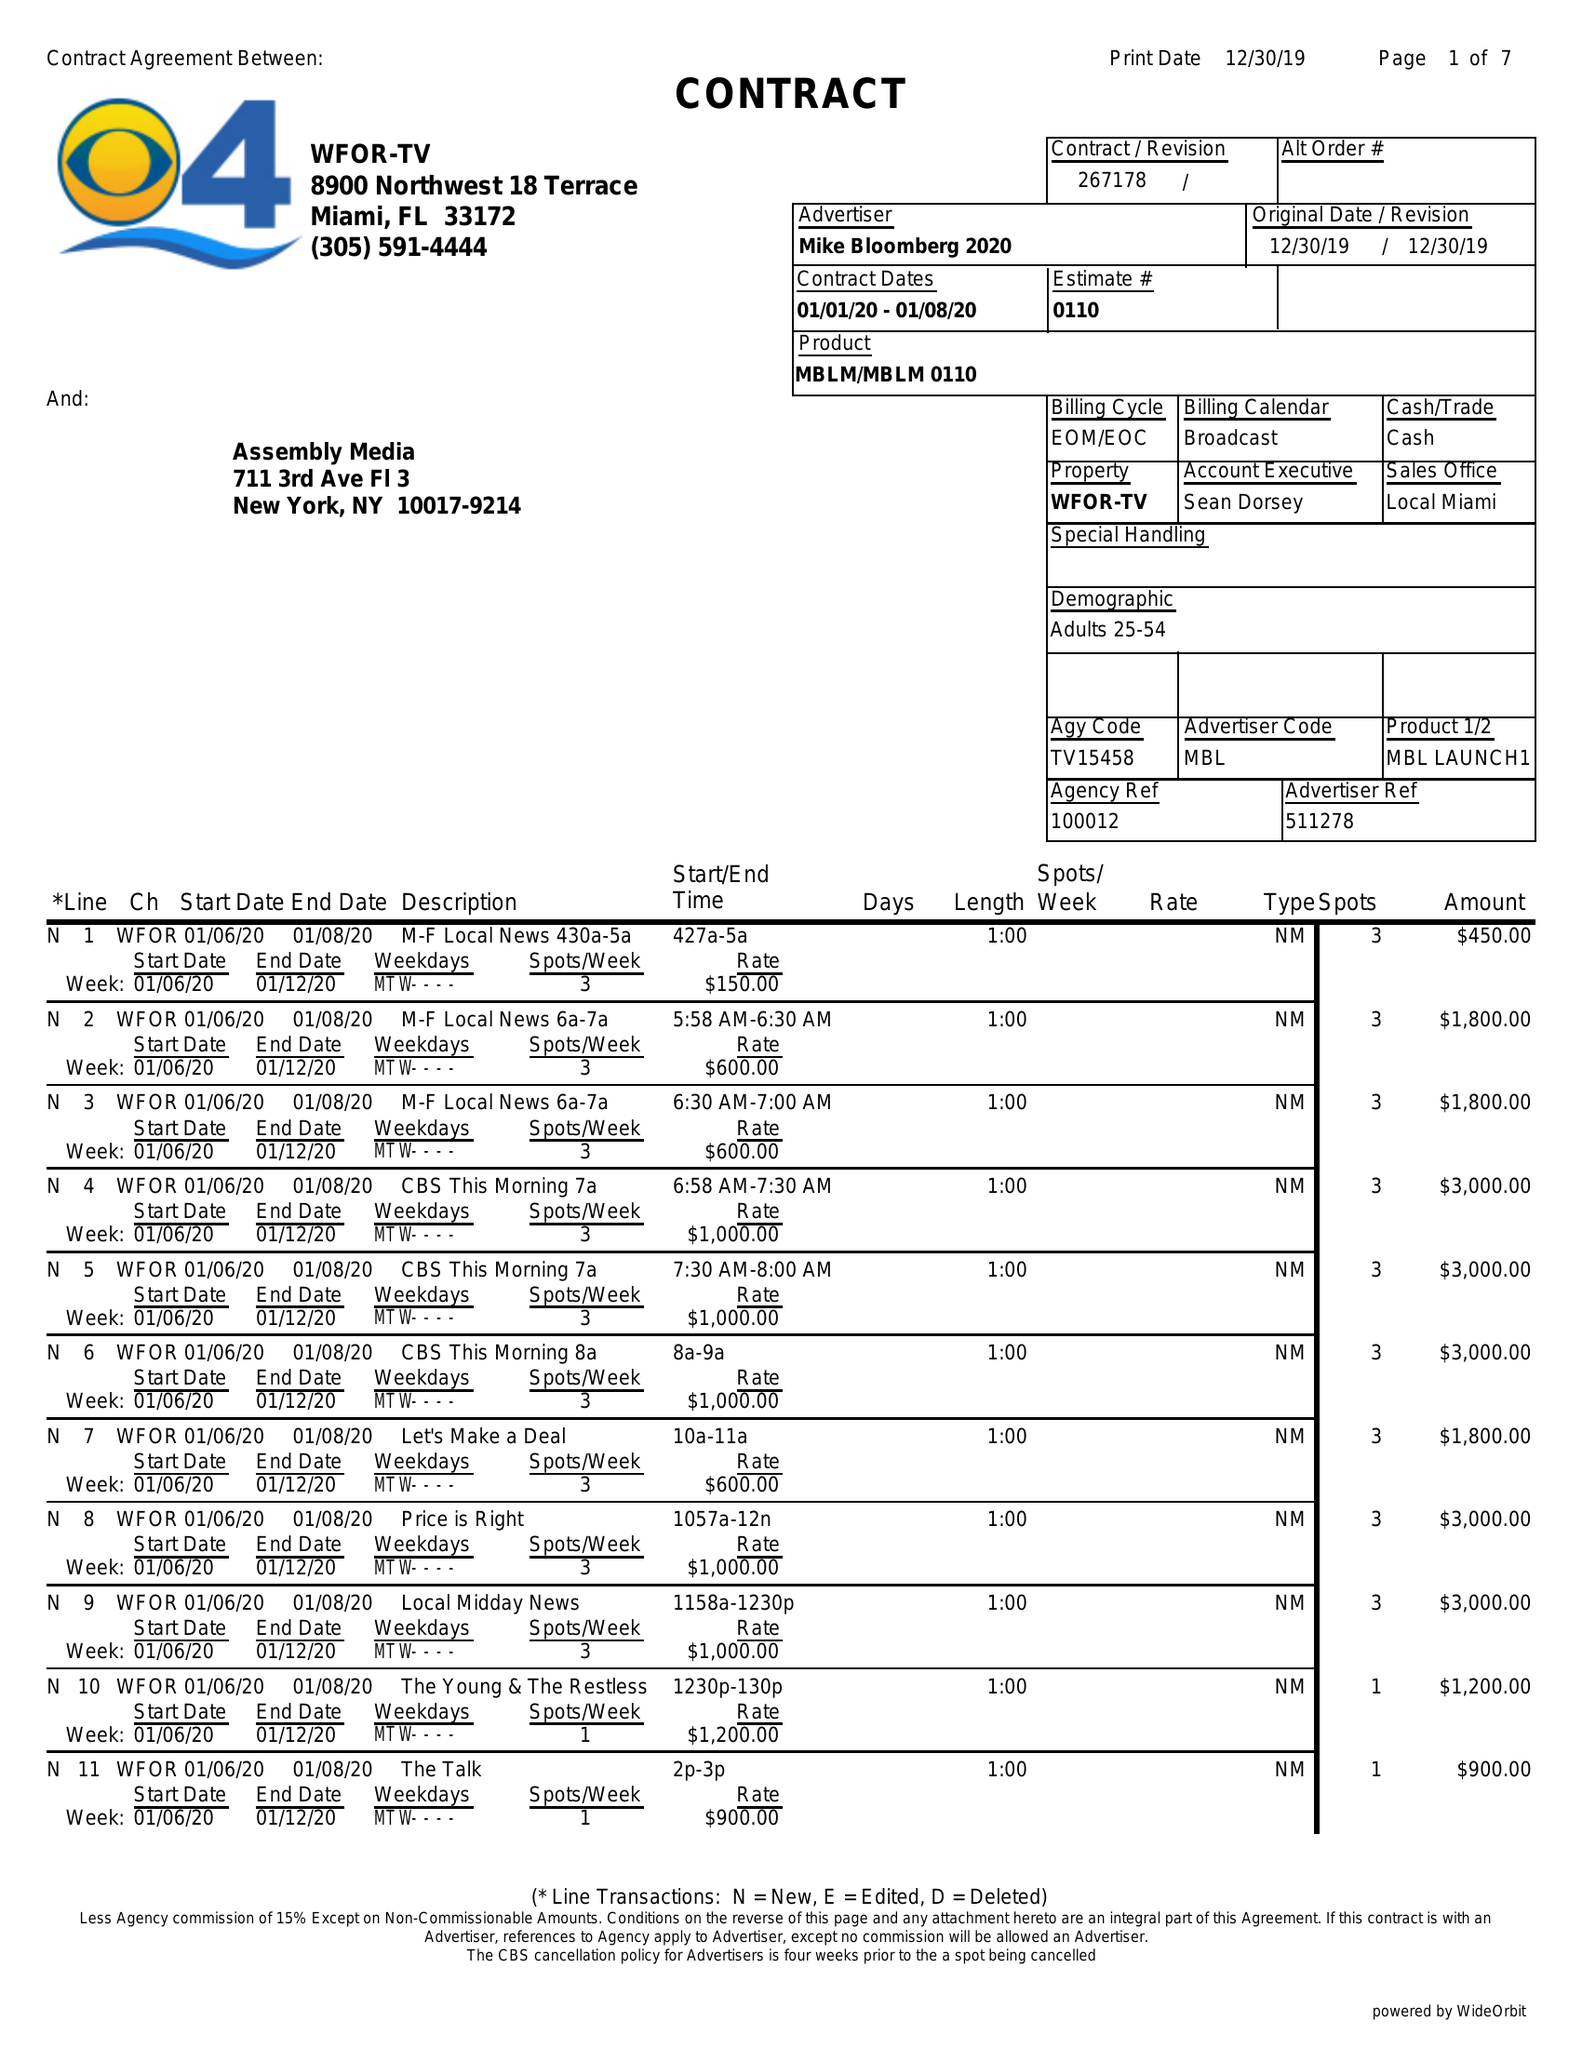What is the value for the gross_amount?
Answer the question using a single word or phrase. 213700.00 